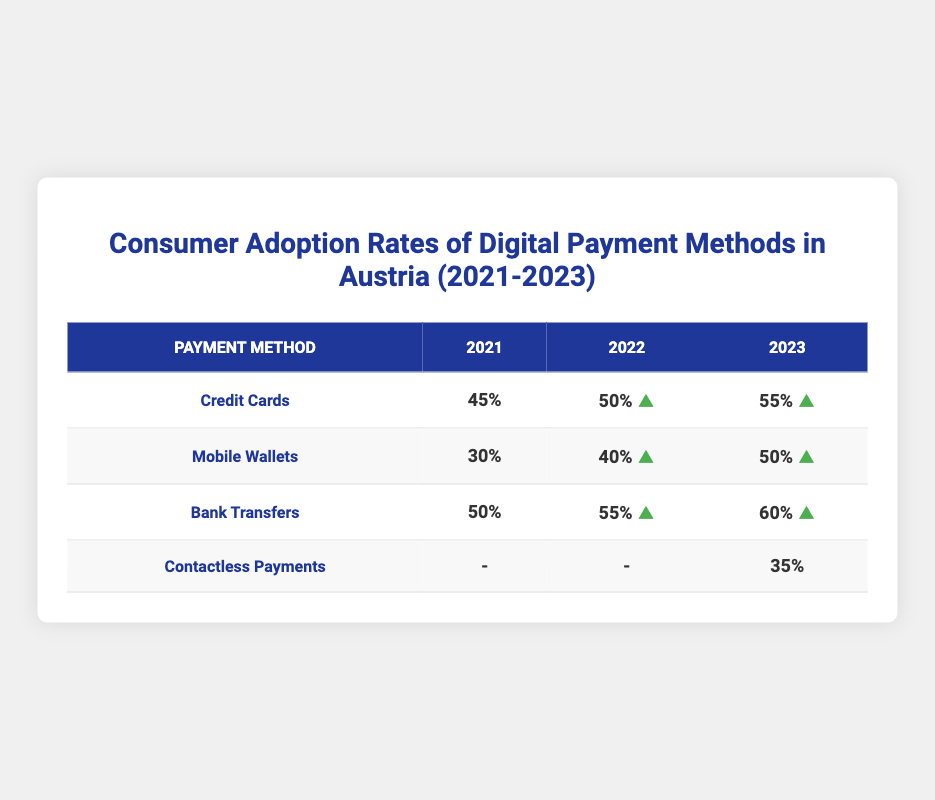What was the adoption rate of credit cards in 2022? In the table under the 'Credit Cards' row for the year 2022, the adoption rate is listed as 50%.
Answer: 50% Which payment method saw the highest increase in adoption rate from 2021 to 2023? To find the highest increase, we calculate the change for each method: Credit Cards (10%), Mobile Wallets (20%), Bank Transfers (10%), and Contactless Payments (35%). Mobile Wallets had the largest increase.
Answer: Mobile Wallets What is the adoption rate of contactless payments in 2021? The table shows a dash under the 'Contactless Payments' row for the year 2021, which indicates that there is no recorded data for that year.
Answer: No data What are the adoption rates for bank transfers for all three years combined? The rates are as follows: 2021 - 50%, 2022 - 55%, and 2023 - 60%. So, the combined adoption rates total 165%.
Answer: 165% Is the adoption rate of mobile wallets higher in 2023 than in 2022? Yes, in 2022 the rate is 40% and in 2023 it is 50%, meaning it increased.
Answer: Yes Calculate the average adoption rate of credit cards from 2021 to 2023. The adoption rates are 45%, 50%, and 55% for those years. Adding these gives 150% and dividing by 3 yields an average of 50%.
Answer: 50% Did the adoption rate for bank transfers increase each year from 2021 to 2023? Yes, from 50% in 2021 to 55% in 2022, and 60% in 2023, indicating an increase each year.
Answer: Yes What is the lowest adoption rate recorded in the table? We look through the adoption rates: 45%, 30%, 50%, 50%, 40%, 55%, 55%, 50%, 60%, 35%. The lowest is 30% for Mobile Wallets in 2021.
Answer: 30% How many payment methods in 2023 have an adoption rate of 50% or above? For 2023, the payment methods with 50% or above are Credit Cards (55%), Mobile Wallets (50%), and Bank Transfers (60%). That totals three methods.
Answer: 3 